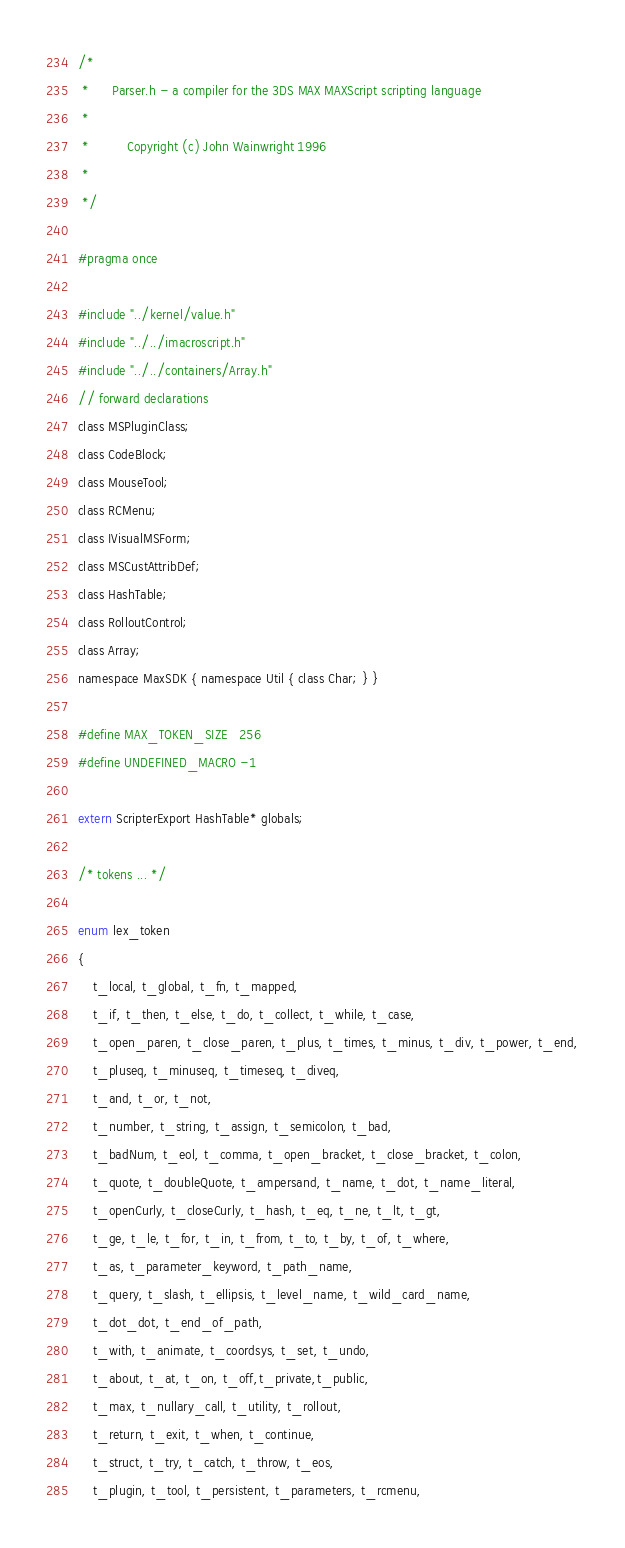<code> <loc_0><loc_0><loc_500><loc_500><_C_>/*	
 *		Parser.h - a compiler for the 3DS MAX MAXScript scripting language
 *
 *			Copyright (c) John Wainwright 1996
 *
 */

#pragma once

#include "../kernel/value.h"
#include "../../imacroscript.h"
#include "../../containers/Array.h"
// forward declarations
class MSPluginClass;
class CodeBlock;
class MouseTool;
class RCMenu;
class IVisualMSForm;
class MSCustAttribDef;
class HashTable;
class RolloutControl;
class Array;
namespace MaxSDK { namespace Util { class Char; } }

#define MAX_TOKEN_SIZE	256
#define UNDEFINED_MACRO -1

extern ScripterExport HashTable* globals;

/* tokens ... */

enum lex_token
{
	t_local, t_global, t_fn, t_mapped,
	t_if, t_then, t_else, t_do, t_collect, t_while, t_case, 
	t_open_paren, t_close_paren, t_plus, t_times, t_minus, t_div, t_power, t_end,
	t_pluseq, t_minuseq, t_timeseq, t_diveq,
	t_and, t_or, t_not,
	t_number, t_string, t_assign, t_semicolon, t_bad,
	t_badNum, t_eol, t_comma, t_open_bracket, t_close_bracket, t_colon,
	t_quote, t_doubleQuote, t_ampersand, t_name, t_dot, t_name_literal,
	t_openCurly, t_closeCurly, t_hash, t_eq, t_ne, t_lt, t_gt,
	t_ge, t_le, t_for, t_in, t_from, t_to, t_by, t_of, t_where,
	t_as, t_parameter_keyword, t_path_name,
	t_query, t_slash, t_ellipsis, t_level_name, t_wild_card_name, 
	t_dot_dot, t_end_of_path,
	t_with, t_animate, t_coordsys, t_set, t_undo,
	t_about, t_at, t_on, t_off,t_private,t_public,
	t_max, t_nullary_call, t_utility, t_rollout,
	t_return, t_exit, t_when, t_continue,
	t_struct, t_try, t_catch, t_throw, t_eos,
	t_plugin, t_tool, t_persistent, t_parameters, t_rcmenu, </code> 